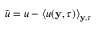Convert formula to latex. <formula><loc_0><loc_0><loc_500><loc_500>\tilde { u } = u - \left \langle u ( y , \tau ) \right \rangle _ { y , \tau }</formula> 